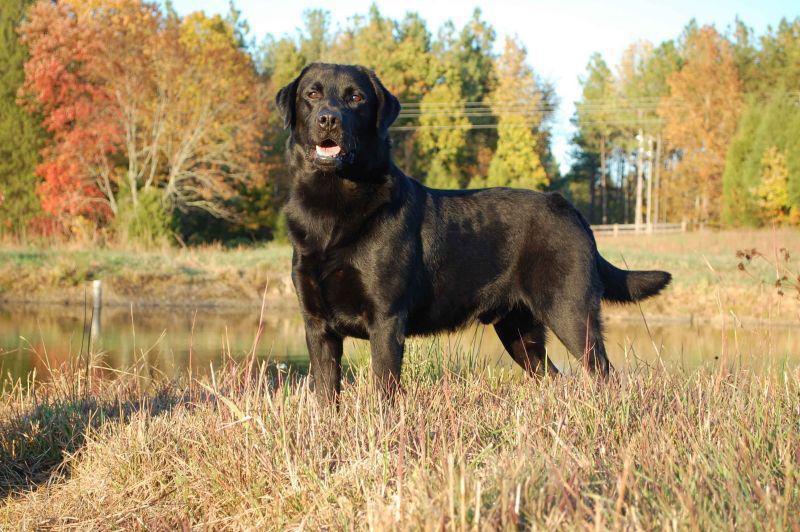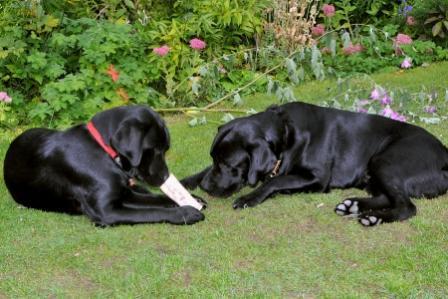The first image is the image on the left, the second image is the image on the right. Assess this claim about the two images: "There are four dogs in total.". Correct or not? Answer yes or no. No. The first image is the image on the left, the second image is the image on the right. Assess this claim about the two images: "There are three black dogs in the grass.". Correct or not? Answer yes or no. Yes. 